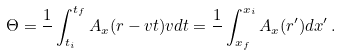Convert formula to latex. <formula><loc_0><loc_0><loc_500><loc_500>\Theta = \frac { 1 } { } \int _ { t _ { i } } ^ { t _ { f } } A _ { x } ( r - v t ) v d t = \frac { 1 } { } \int _ { x _ { f } } ^ { x _ { i } } A _ { x } ( r ^ { \prime } ) d x ^ { \prime } \, .</formula> 